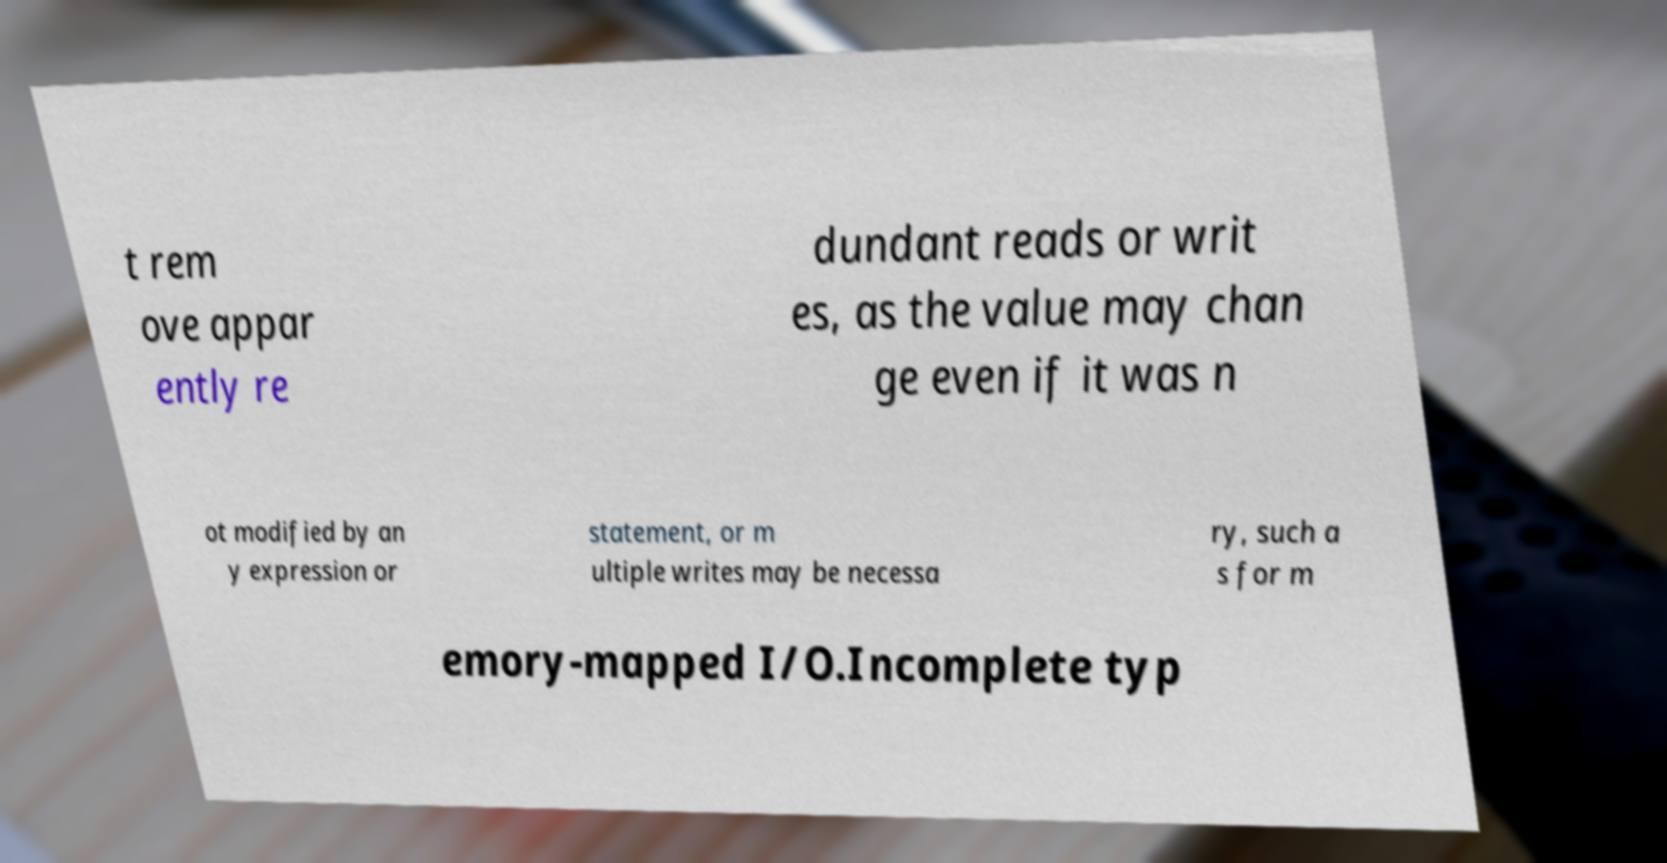Can you accurately transcribe the text from the provided image for me? t rem ove appar ently re dundant reads or writ es, as the value may chan ge even if it was n ot modified by an y expression or statement, or m ultiple writes may be necessa ry, such a s for m emory-mapped I/O.Incomplete typ 